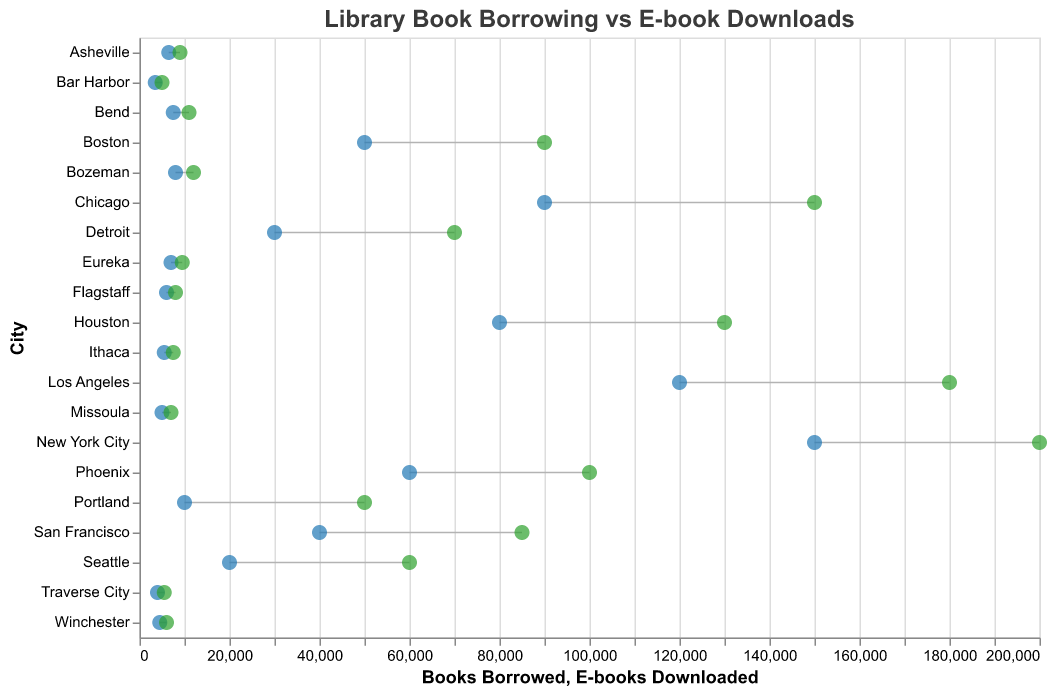How many urban areas are included in the plot? The visual lists the cities and categorizes them by area. Count the number of cities labeled as "Urban".
Answer: 10 Which city has the highest number of e-books downloaded? By looking at the length of the lines representing e-book downloads and observing their end points, the city with the furthest right endpoint under "E-books Downloaded" is New York City.
Answer: New York City Do rural or urban areas have more books borrowed on average? Calculate the average number of books borrowed for urban cities and rural cities by summing their borrowing numbers and dividing by the number of cities in each category. Urban average: (150000 + 120000 + 90000 + 80000 + 60000 + 50000 + 40000 + 30000 + 20000 + 10000)/10 = 65000. Rural average: (8000 + 7500 + 7000 + 6500 + 6000 + 5500 + 5000 + 4500 + 4000 + 3500)/10 = 5750.
Answer: Urban Which urban city has the smallest difference between books borrowed and e-books downloaded? Calculate the absolute differences for each urban city and find the smallest one. New York City: 50000, Los Angeles: 60000, Chicago: 60000, Houston: 50000, Phoenix: 40000, Boston: 40000, San Francisco: 45000, Detroit: 40000, Seattle: 40000, Portland: 40000. The smallest differences are 40000 (Phoenix, Boston, Detroit, Seattle, Portland).
Answer: Phoenix, Boston, Detroit, Seattle, Portland What is the total number of e-books downloaded in rural areas? Sum up the "E-books Downloaded" figures for all rural cities: 12000 + 11000 + 9500 + 9000 + 8000 + 7500 + 7000 + 6000 + 5500 + 5000 = 85500.
Answer: 85500 Is there any city where the number of books borrowed exceeds the number of e-books downloaded? Compare the "Books Borrowed" and "E-books Downloaded" values for each city and identify if any "Books Borrowed" value is larger. None of the cities has “Books Borrowed” exceeding “E-books Downloaded”.
Answer: No How many cities have e-book downloads greater than 10000? Count the number of cities where the "E-books Downloaded" value exceeds 10000. The cities are New York City, Los Angeles, Chicago, Houston, Phoenix, Boston, San Francisco, and Bozeman.
Answer: 8 Which city has the closest values for books borrowed and e-books downloaded? Calculate the absolute differences between books borrowed and e-books downloaded for each city and find the smallest difference. Traverse City: 1500.
Answer: Traverse City 